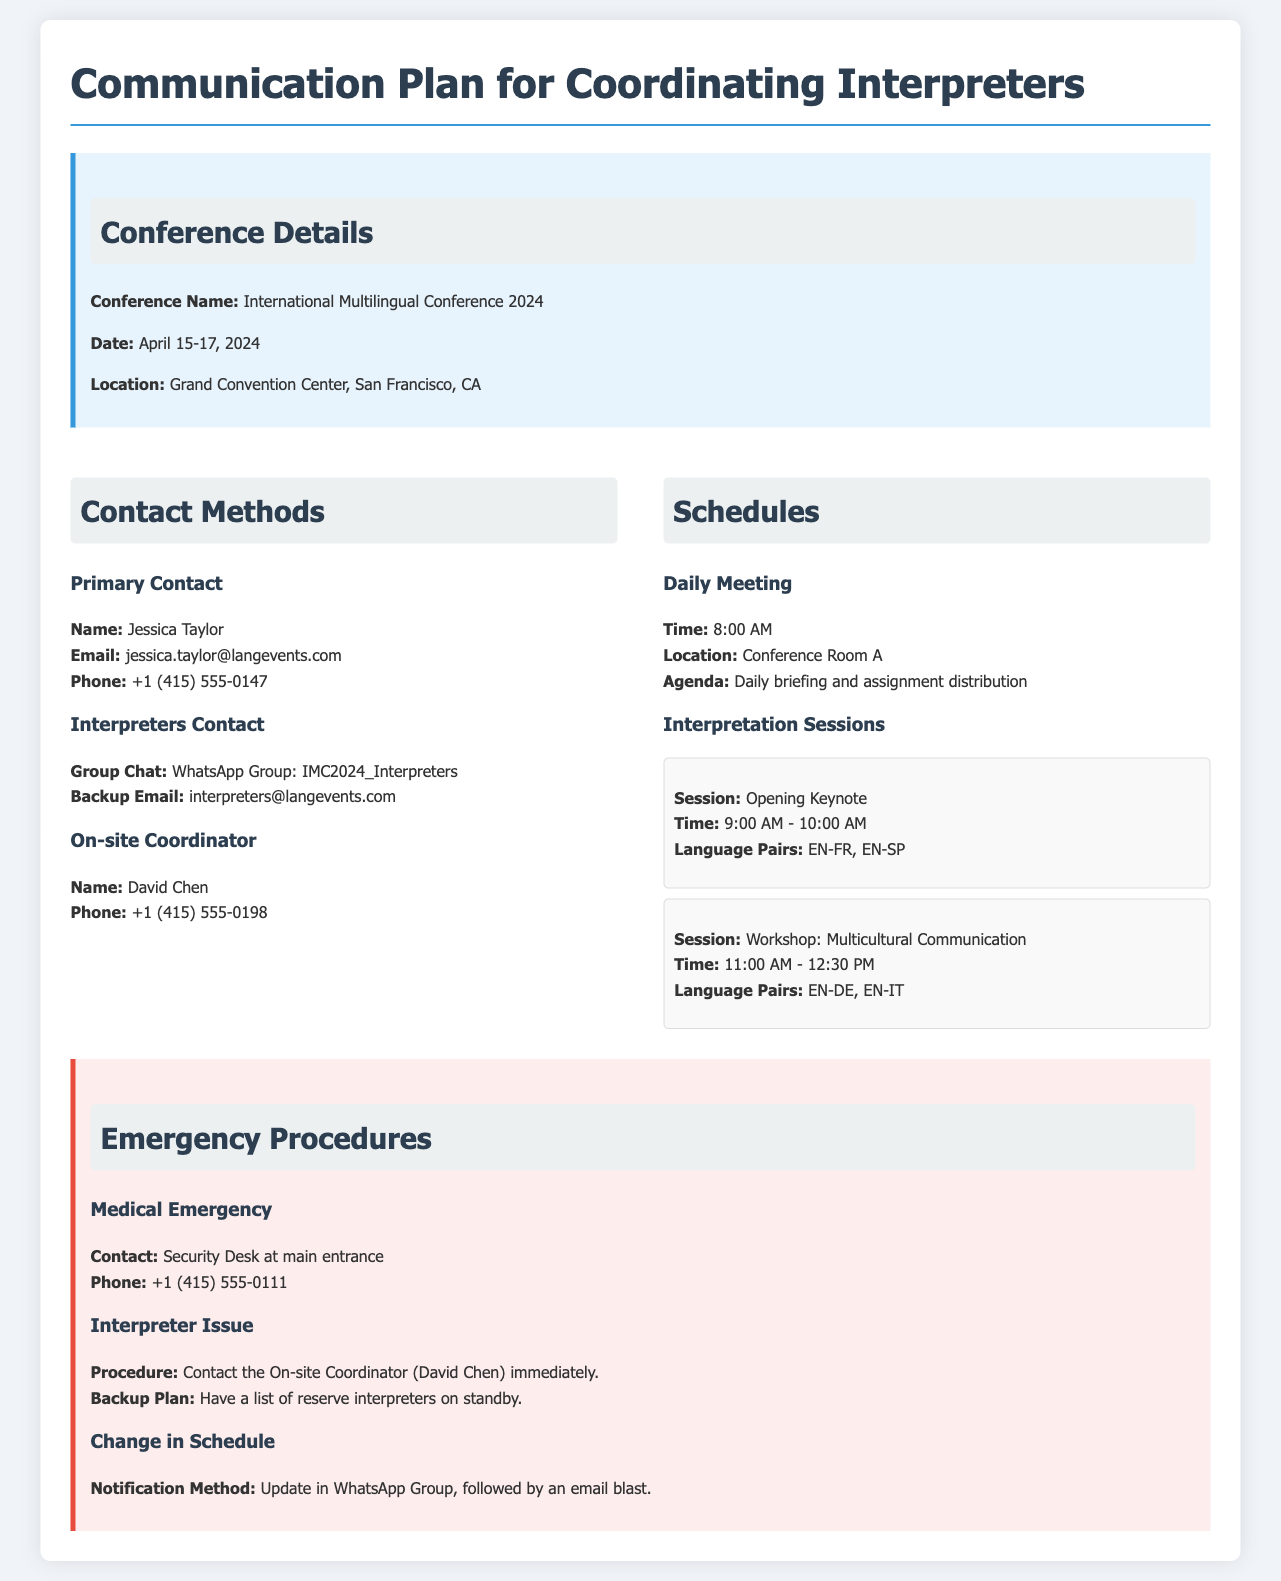What is the conference name? The conference name is stated in the contact information section of the document.
Answer: International Multilingual Conference 2024 Who is the primary contact for the conference? The name of the primary contact is provided under the contact methods section.
Answer: Jessica Taylor What is the time for the daily meeting? The time for the daily meeting is mentioned in the schedules section for daily meetings.
Answer: 8:00 AM What is the phone number for the on-site coordinator? The phone number for the on-site coordinator is specified in the contact methods section.
Answer: +1 (415) 555-0198 What should you do in case of an interpreter issue? The procedure for dealing with an interpreter issue is outlined in the emergency procedures section.
Answer: Contact the On-site Coordinator How can schedule changes be communicated? The notification method for change in schedule is stated in the emergency procedures section.
Answer: Update in WhatsApp Group, followed by an email blast 